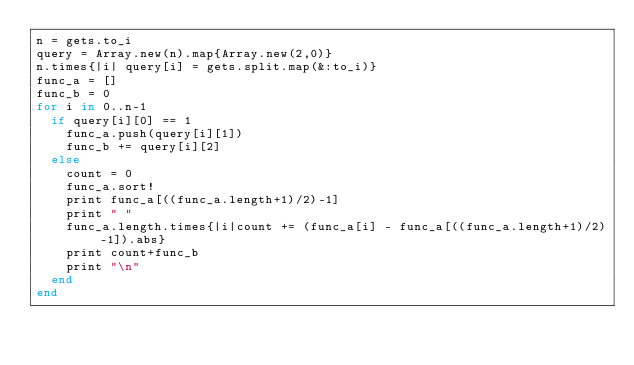Convert code to text. <code><loc_0><loc_0><loc_500><loc_500><_Ruby_>n = gets.to_i
query = Array.new(n).map{Array.new(2,0)}
n.times{|i| query[i] = gets.split.map(&:to_i)}
func_a = []
func_b = 0
for i in 0..n-1
  if query[i][0] == 1
    func_a.push(query[i][1])
    func_b += query[i][2]
  else
    count = 0
    func_a.sort!
    print func_a[((func_a.length+1)/2)-1]
    print " "
    func_a.length.times{|i|count += (func_a[i] - func_a[((func_a.length+1)/2)-1]).abs}
    print count+func_b
    print "\n"
  end
end
</code> 